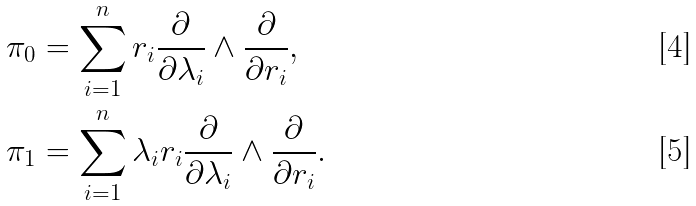<formula> <loc_0><loc_0><loc_500><loc_500>\pi _ { 0 } & = \sum _ { i = 1 } ^ { n } r _ { i } \frac { \partial } { \partial \lambda _ { i } } \wedge \frac { \partial } { \partial r _ { i } } , \\ \pi _ { 1 } & = \sum _ { i = 1 } ^ { n } \lambda _ { i } r _ { i } \frac { \partial } { \partial \lambda _ { i } } \wedge \frac { \partial } { \partial r _ { i } } .</formula> 